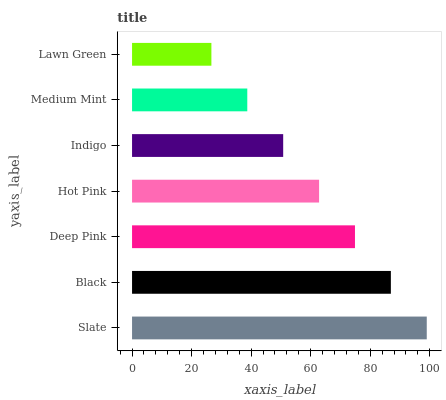Is Lawn Green the minimum?
Answer yes or no. Yes. Is Slate the maximum?
Answer yes or no. Yes. Is Black the minimum?
Answer yes or no. No. Is Black the maximum?
Answer yes or no. No. Is Slate greater than Black?
Answer yes or no. Yes. Is Black less than Slate?
Answer yes or no. Yes. Is Black greater than Slate?
Answer yes or no. No. Is Slate less than Black?
Answer yes or no. No. Is Hot Pink the high median?
Answer yes or no. Yes. Is Hot Pink the low median?
Answer yes or no. Yes. Is Black the high median?
Answer yes or no. No. Is Indigo the low median?
Answer yes or no. No. 